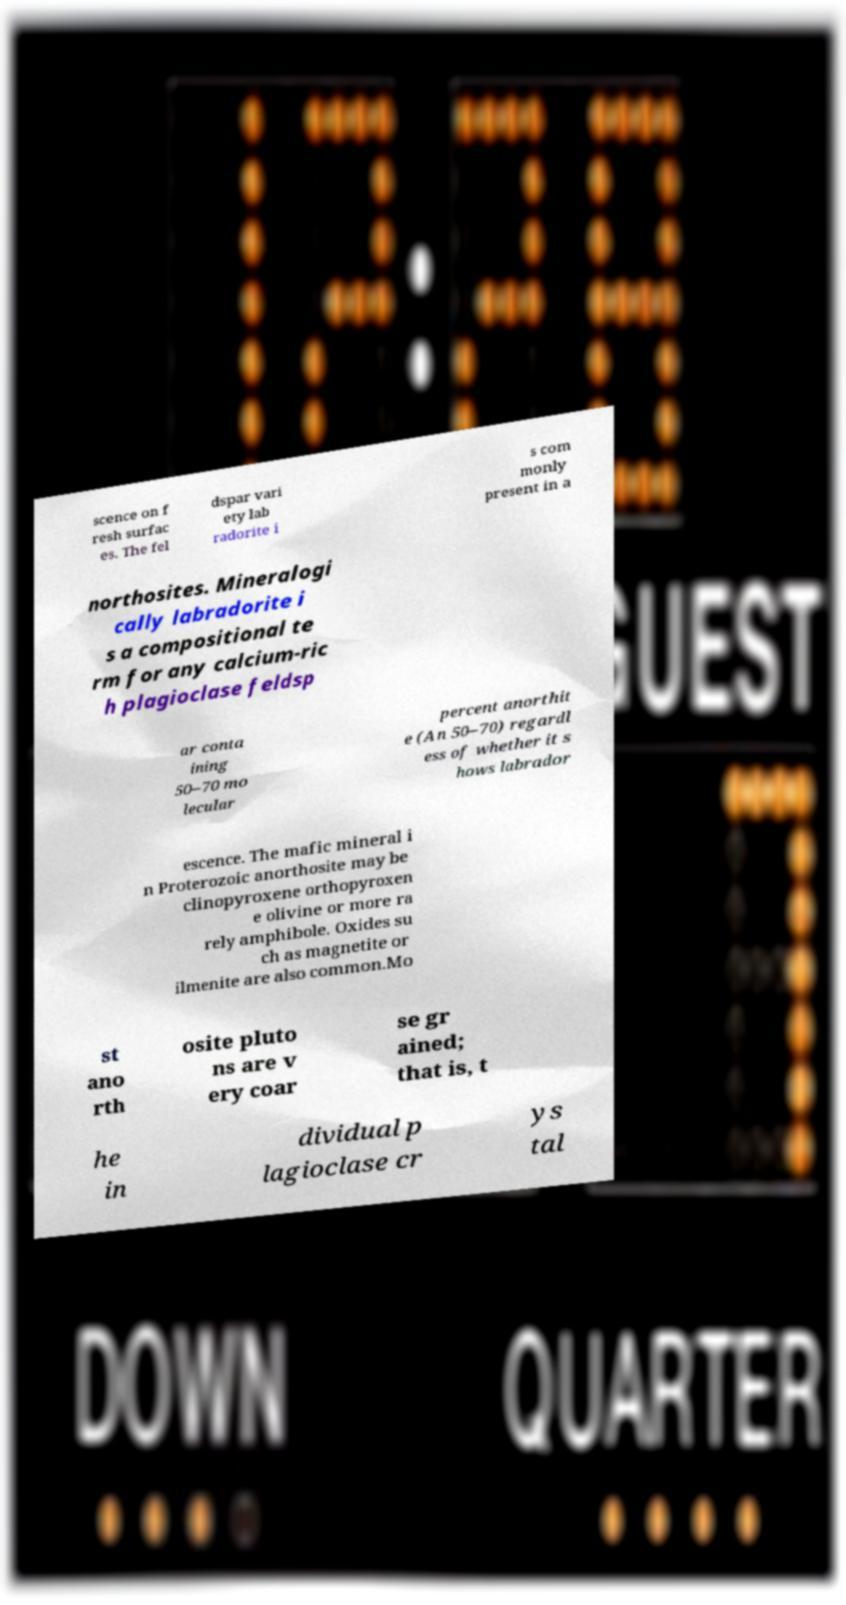What messages or text are displayed in this image? I need them in a readable, typed format. scence on f resh surfac es. The fel dspar vari ety lab radorite i s com monly present in a northosites. Mineralogi cally labradorite i s a compositional te rm for any calcium-ric h plagioclase feldsp ar conta ining 50–70 mo lecular percent anorthit e (An 50–70) regardl ess of whether it s hows labrador escence. The mafic mineral i n Proterozoic anorthosite may be clinopyroxene orthopyroxen e olivine or more ra rely amphibole. Oxides su ch as magnetite or ilmenite are also common.Mo st ano rth osite pluto ns are v ery coar se gr ained; that is, t he in dividual p lagioclase cr ys tal 